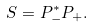Convert formula to latex. <formula><loc_0><loc_0><loc_500><loc_500>S = P _ { - } ^ { * } P _ { + } .</formula> 